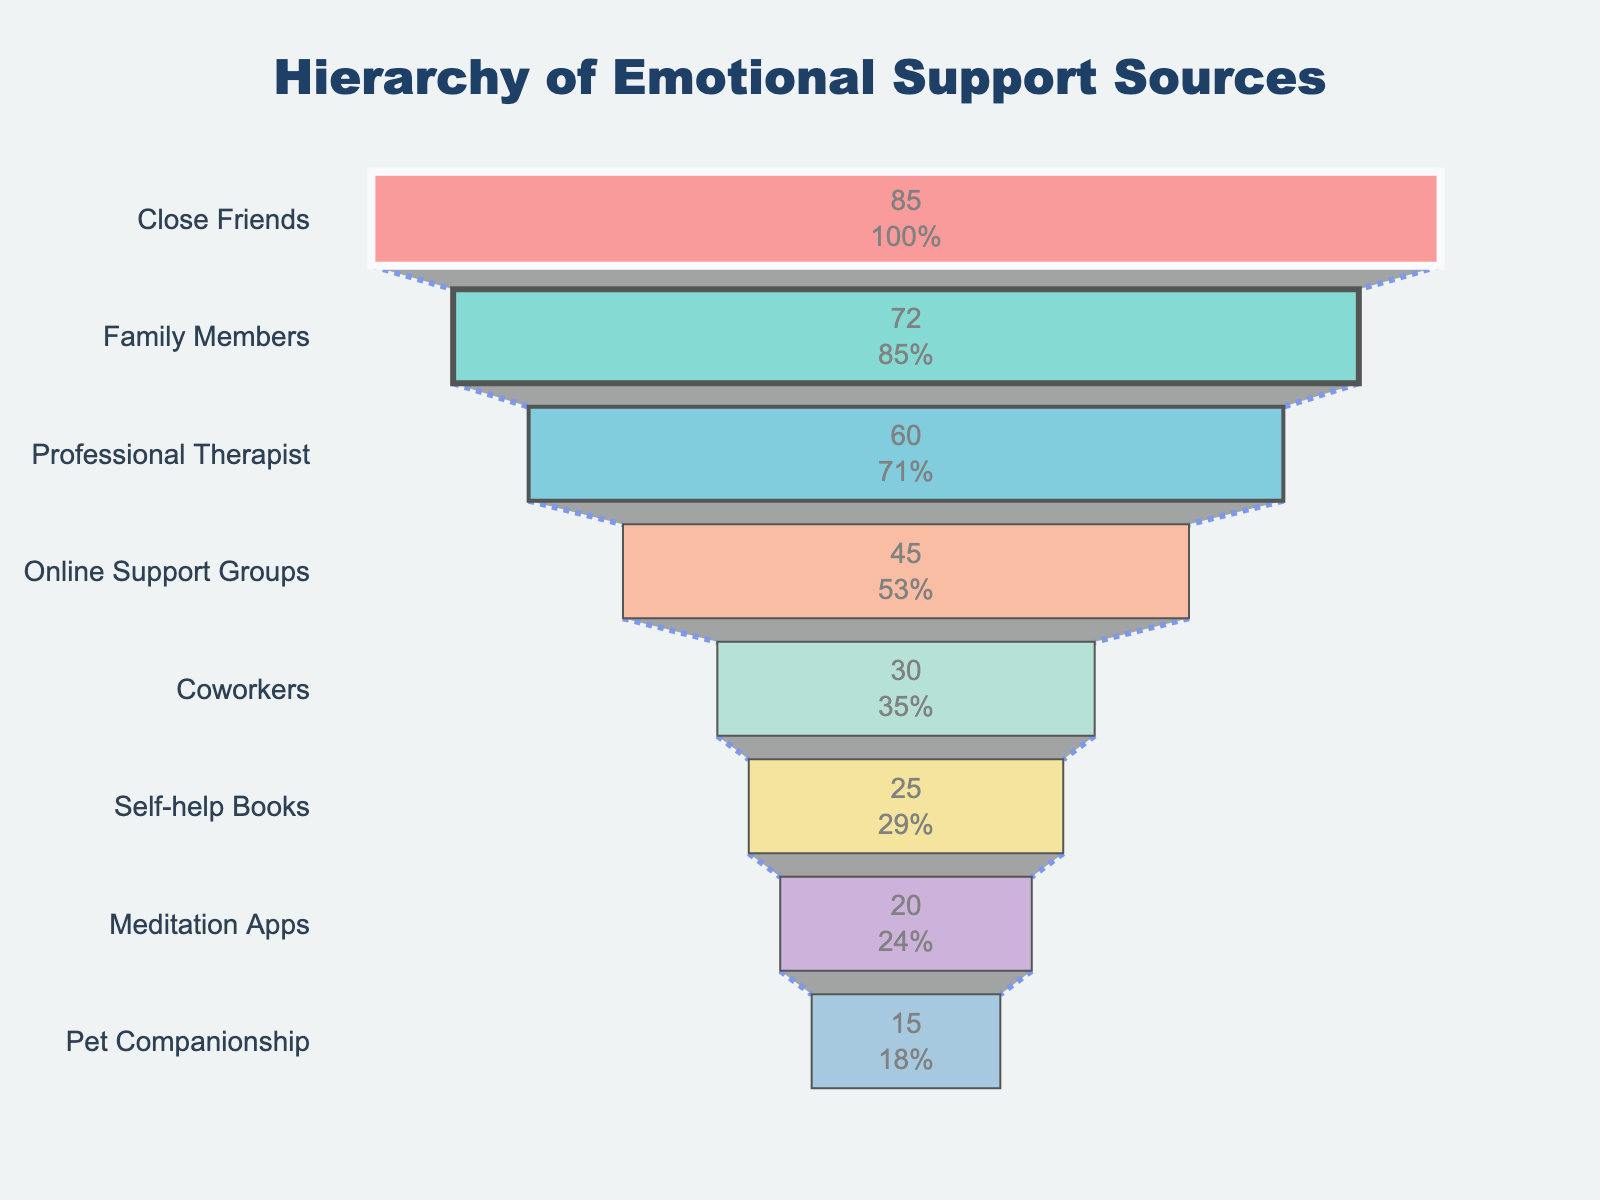what is the title of the figure? The title is displayed prominently at the top center of the figure. It reads "Hierarchy of Emotional Support Sources".
Answer: Hierarchy of Emotional Support Sources Which source of emotional support has the highest utilization rate? The funnel chart shows "Close Friends" at the top with the highest utilization rate when sorted in descending order.
Answer: Close Friends How many different sources of emotional support are represented in the funnel chart? By counting all the categories listed along the y-axis, we can see there are 8 different sources.
Answer: 8 What is the utilization rate for Professional Therapist? Locate "Professional Therapist" on the y-axis, then check the corresponding utilization rate displayed on the funnel.
Answer: 60 What is the difference in utilization rate between Family Members and Online Support Groups? Find the utilization rates for both Family Members (72) and Online Support Groups (45), then subtract the smaller number from the larger one. 72 - 45 = 27.
Answer: 27 Which source of emotional support has the lowest utilization rate? The source at the bottom of the funnel chart has the lowest utilization rate. This is "Pet Companionship".
Answer: Pet Companionship How do the utilization rates of Self-help Books and Meditation Apps compare? The funnel chart shows that the utilization rate for Self-help Books is 25, while for Meditation Apps it is 20. 25 is greater than 20, so Self-help Books have a higher utilization rate.
Answer: Self-help Books have a higher utilization rate What is the combined utilization rate of Close Friends and Family Members? Add the utilization rates for Close Friends (85) and Family Members (72). The combined rate is 85 + 72 = 157.
Answer: 157 How much does the utilization rate decrease from Professional Therapist to Pet Companionship? The utilization rate for Professional Therapist is 60, and for Pet Companionship it is 15. The decrease is 60 - 15 = 45.
Answer: 45 